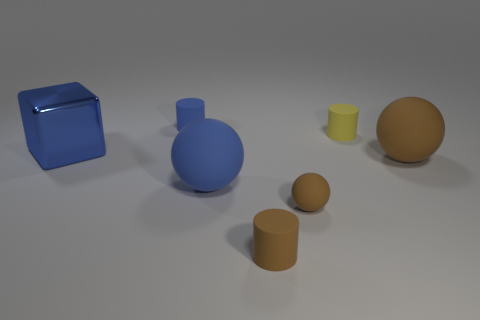What is the color of the small rubber sphere?
Offer a terse response. Brown. What number of tiny matte cylinders have the same color as the large shiny object?
Make the answer very short. 1. Are there any small blue rubber things behind the big blue shiny object?
Provide a short and direct response. Yes. Are there an equal number of large blocks behind the large blue rubber object and shiny things that are to the right of the tiny blue matte cylinder?
Your answer should be very brief. No. There is a thing that is behind the yellow thing; is its size the same as the thing that is on the left side of the tiny blue cylinder?
Provide a succinct answer. No. What shape is the blue matte object that is behind the large blue object that is on the left side of the cylinder that is behind the small yellow thing?
Your answer should be very brief. Cylinder. Is there anything else that is made of the same material as the blue block?
Ensure brevity in your answer.  No. There is a brown thing that is the same shape as the tiny yellow rubber object; what size is it?
Ensure brevity in your answer.  Small. What color is the tiny rubber cylinder that is both on the left side of the yellow rubber thing and in front of the small blue rubber thing?
Offer a very short reply. Brown. Is the yellow cylinder made of the same material as the object that is behind the yellow object?
Make the answer very short. Yes. 